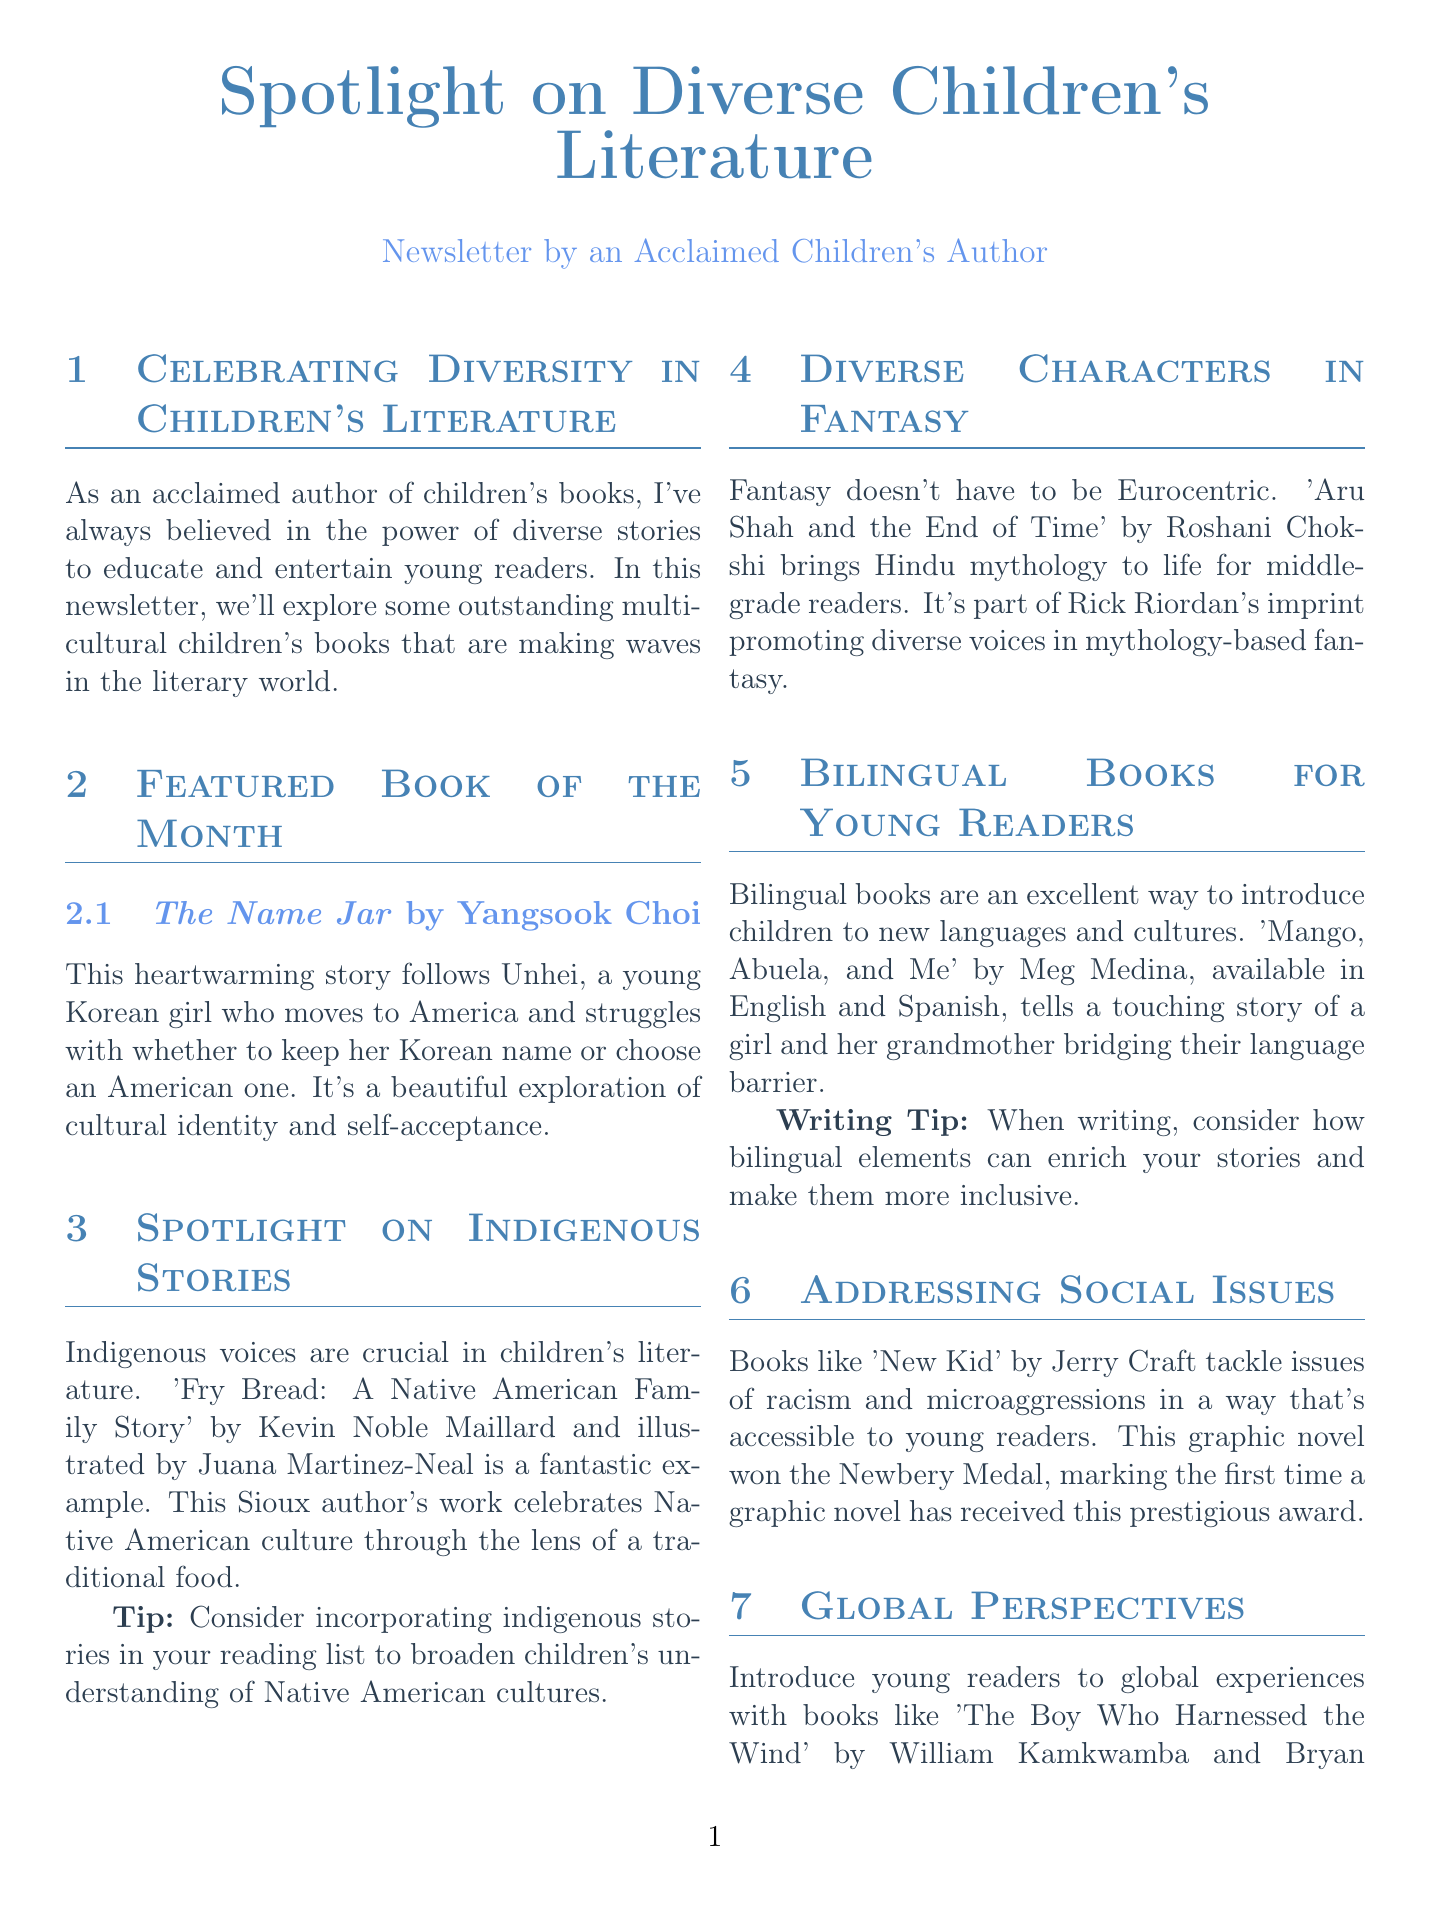What is the title of the newsletter? The title of the newsletter is prominently displayed at the top, stating the focus on diverse children's literature.
Answer: Spotlight on Diverse Children's Literature Who is the author of the featured book "The Name Jar"? The author is mentioned alongside the book title in the Featured Book section.
Answer: Yangsook Choi What is the central theme of "The Name Jar"? This theme is explored in the description of the book in the newsletter.
Answer: Cultural identity and self-acceptance What event is scheduled for January 26, 2024? The date is listed under Upcoming Diverse Literature Events in the newsletter.
Answer: Multicultural Children's Book Day Which book highlights Native American culture? The newsletter features this specific book in the Spotlight on Indigenous Stories section.
Answer: Fry Bread: A Native American Family Story What type of books does "Mango, Abuela, and Me" represent? This is specified in the description of the Bilingual Books section.
Answer: Bilingual books What key writing advice is provided in the Writing Tip of the Month? The newsletter gives this important writing tip for authors crafting diverse characters.
Answer: Research is key How many events are listed in the Upcoming Diverse Literature Events section? The total count of events can be determined from the listed items in that section.
Answer: Two 